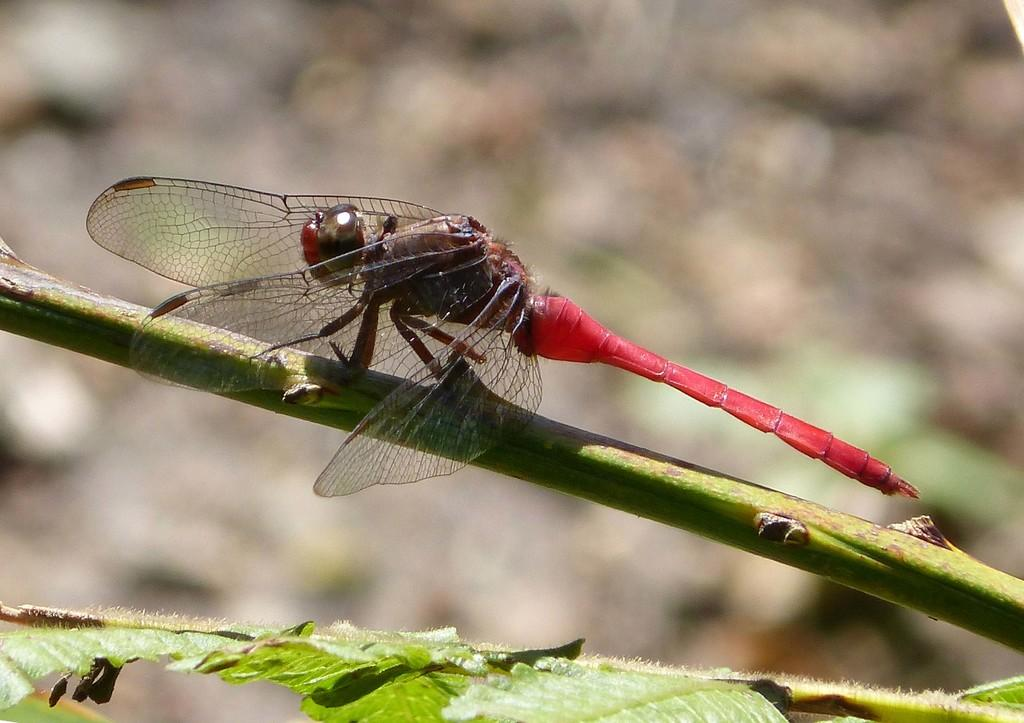What type of insect is in the image? There is a red color grasshopper in the image. Where is the grasshopper located? The grasshopper is sitting on a plant branch. What can be seen in the front bottom side of the image? There are green leaves in the front bottom side of the image. How would you describe the background of the image? The background of the image is blurred. What song is the grasshopper singing in the image? The grasshopper is not singing a song in the image; it is simply sitting on a plant branch. 